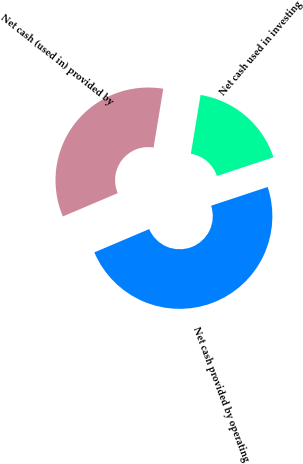<chart> <loc_0><loc_0><loc_500><loc_500><pie_chart><fcel>Net cash provided by operating<fcel>Net cash used in investing<fcel>Net cash (used in) provided by<nl><fcel>48.7%<fcel>17.31%<fcel>33.99%<nl></chart> 